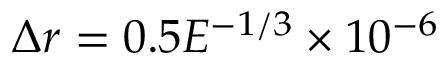Convert formula to latex. <formula><loc_0><loc_0><loc_500><loc_500>\Delta r = 0 . 5 E ^ { - 1 / 3 } \times 1 0 ^ { - 6 }</formula> 